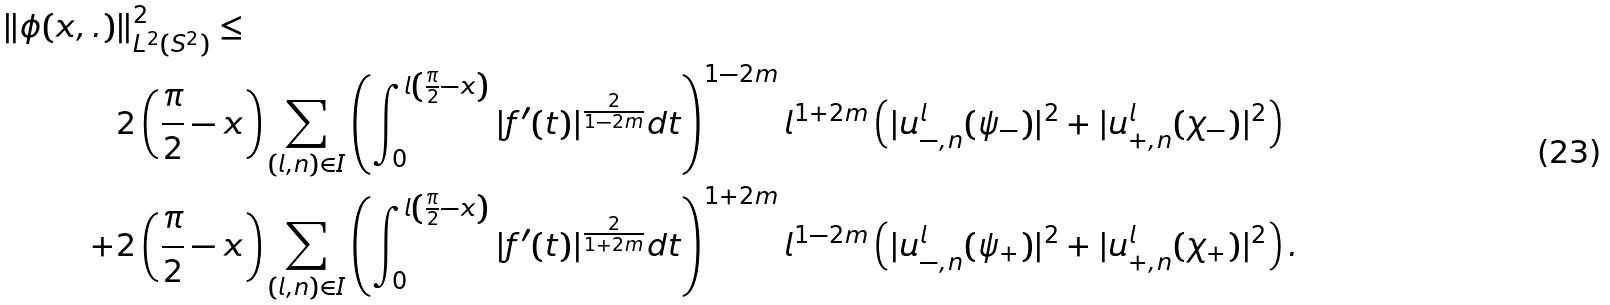Convert formula to latex. <formula><loc_0><loc_0><loc_500><loc_500>\| \phi ( x , . ) & \| _ { L ^ { 2 } ( S ^ { 2 } ) } ^ { 2 } \leq \\ & 2 \left ( \frac { \pi } { 2 } - x \right ) \sum _ { ( l , n ) \in I } \left ( \int _ { 0 } ^ { l \left ( \frac { \pi } { 2 } - x \right ) } | f ^ { \prime } ( t ) | ^ { \frac { 2 } { 1 - 2 m } } d t \right ) ^ { 1 - 2 m } l ^ { 1 + 2 m } \left ( | u ^ { l } _ { - , n } ( \psi _ { - } ) | ^ { 2 } + | u ^ { l } _ { + , n } ( \chi _ { - } ) | ^ { 2 } \right ) \\ + & 2 \left ( \frac { \pi } { 2 } - x \right ) \sum _ { ( l , n ) \in I } \left ( \int _ { 0 } ^ { l \left ( \frac { \pi } { 2 } - x \right ) } | f ^ { \prime } ( t ) | ^ { \frac { 2 } { 1 + 2 m } } d t \right ) ^ { 1 + 2 m } l ^ { 1 - 2 m } \left ( | u ^ { l } _ { - , n } ( \psi _ { + } ) | ^ { 2 } + | u ^ { l } _ { + , n } ( \chi _ { + } ) | ^ { 2 } \right ) .</formula> 